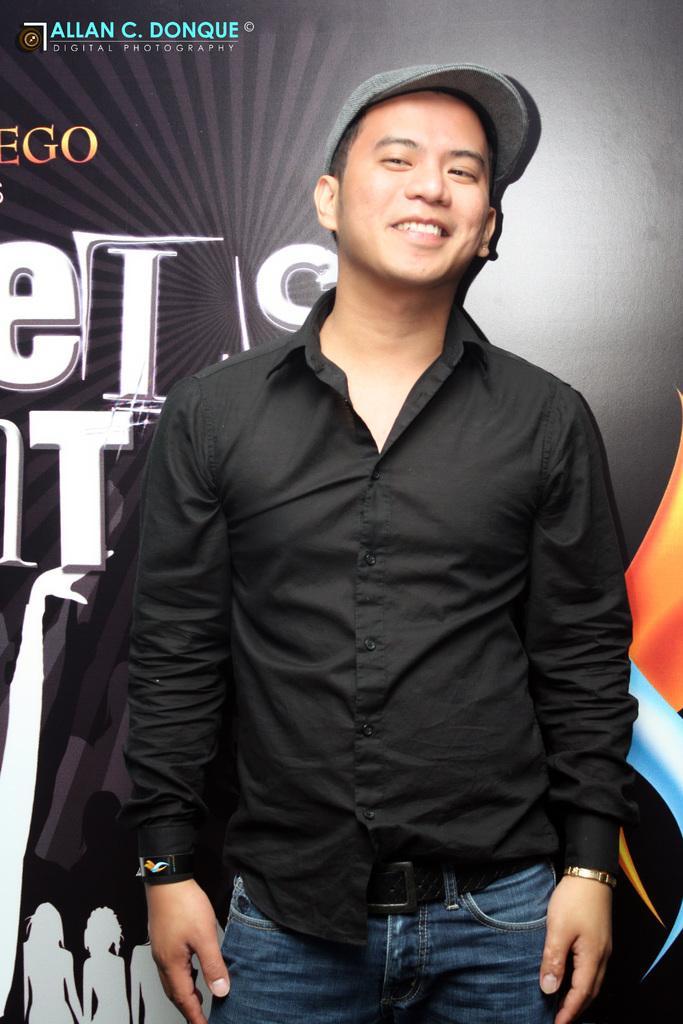In one or two sentences, can you explain what this image depicts? In this picture man is standing in the center wearing a black colour shirt and a grey colour hat and is having smile on his face. In the background there is black colour banner. 